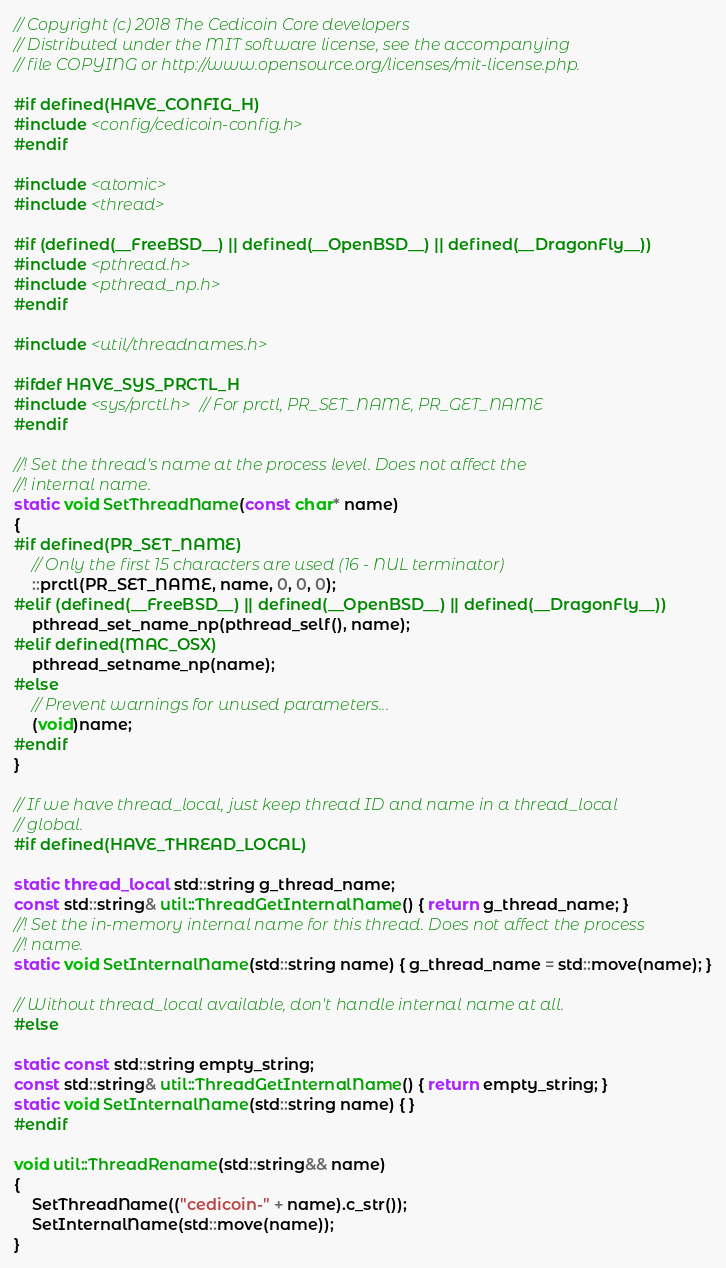<code> <loc_0><loc_0><loc_500><loc_500><_C++_>// Copyright (c) 2018 The Cedicoin Core developers
// Distributed under the MIT software license, see the accompanying
// file COPYING or http://www.opensource.org/licenses/mit-license.php.

#if defined(HAVE_CONFIG_H)
#include <config/cedicoin-config.h>
#endif

#include <atomic>
#include <thread>

#if (defined(__FreeBSD__) || defined(__OpenBSD__) || defined(__DragonFly__))
#include <pthread.h>
#include <pthread_np.h>
#endif

#include <util/threadnames.h>

#ifdef HAVE_SYS_PRCTL_H
#include <sys/prctl.h> // For prctl, PR_SET_NAME, PR_GET_NAME
#endif

//! Set the thread's name at the process level. Does not affect the
//! internal name.
static void SetThreadName(const char* name)
{
#if defined(PR_SET_NAME)
    // Only the first 15 characters are used (16 - NUL terminator)
    ::prctl(PR_SET_NAME, name, 0, 0, 0);
#elif (defined(__FreeBSD__) || defined(__OpenBSD__) || defined(__DragonFly__))
    pthread_set_name_np(pthread_self(), name);
#elif defined(MAC_OSX)
    pthread_setname_np(name);
#else
    // Prevent warnings for unused parameters...
    (void)name;
#endif
}

// If we have thread_local, just keep thread ID and name in a thread_local
// global.
#if defined(HAVE_THREAD_LOCAL)

static thread_local std::string g_thread_name;
const std::string& util::ThreadGetInternalName() { return g_thread_name; }
//! Set the in-memory internal name for this thread. Does not affect the process
//! name.
static void SetInternalName(std::string name) { g_thread_name = std::move(name); }

// Without thread_local available, don't handle internal name at all.
#else

static const std::string empty_string;
const std::string& util::ThreadGetInternalName() { return empty_string; }
static void SetInternalName(std::string name) { }
#endif

void util::ThreadRename(std::string&& name)
{
    SetThreadName(("cedicoin-" + name).c_str());
    SetInternalName(std::move(name));
}
</code> 